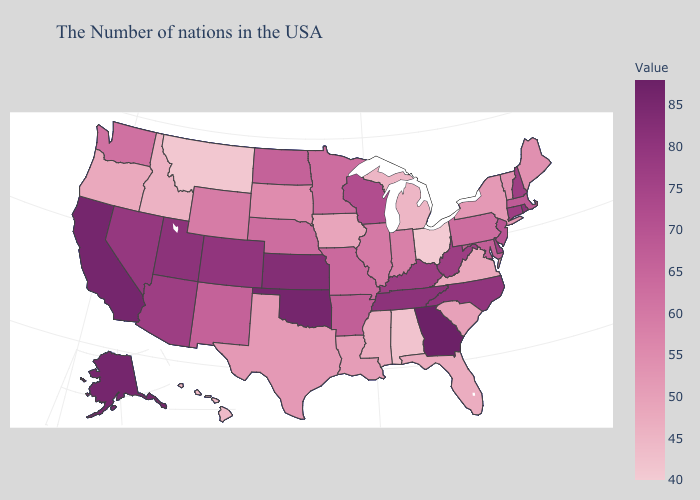Does Georgia have the highest value in the USA?
Be succinct. Yes. Does Virginia have the highest value in the South?
Keep it brief. No. Among the states that border Pennsylvania , does Maryland have the lowest value?
Keep it brief. No. Does West Virginia have a lower value than Oklahoma?
Concise answer only. Yes. Does Rhode Island have a higher value than California?
Write a very short answer. No. Which states have the lowest value in the MidWest?
Write a very short answer. Ohio. 